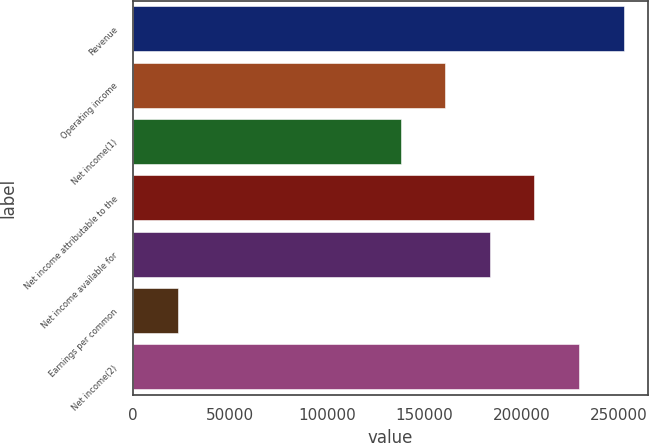Convert chart to OTSL. <chart><loc_0><loc_0><loc_500><loc_500><bar_chart><fcel>Revenue<fcel>Operating income<fcel>Net income(1)<fcel>Net income attributable to the<fcel>Net income available for<fcel>Earnings per common<fcel>Net income(2)<nl><fcel>252728<fcel>160827<fcel>137852<fcel>206778<fcel>183803<fcel>22976<fcel>229753<nl></chart> 